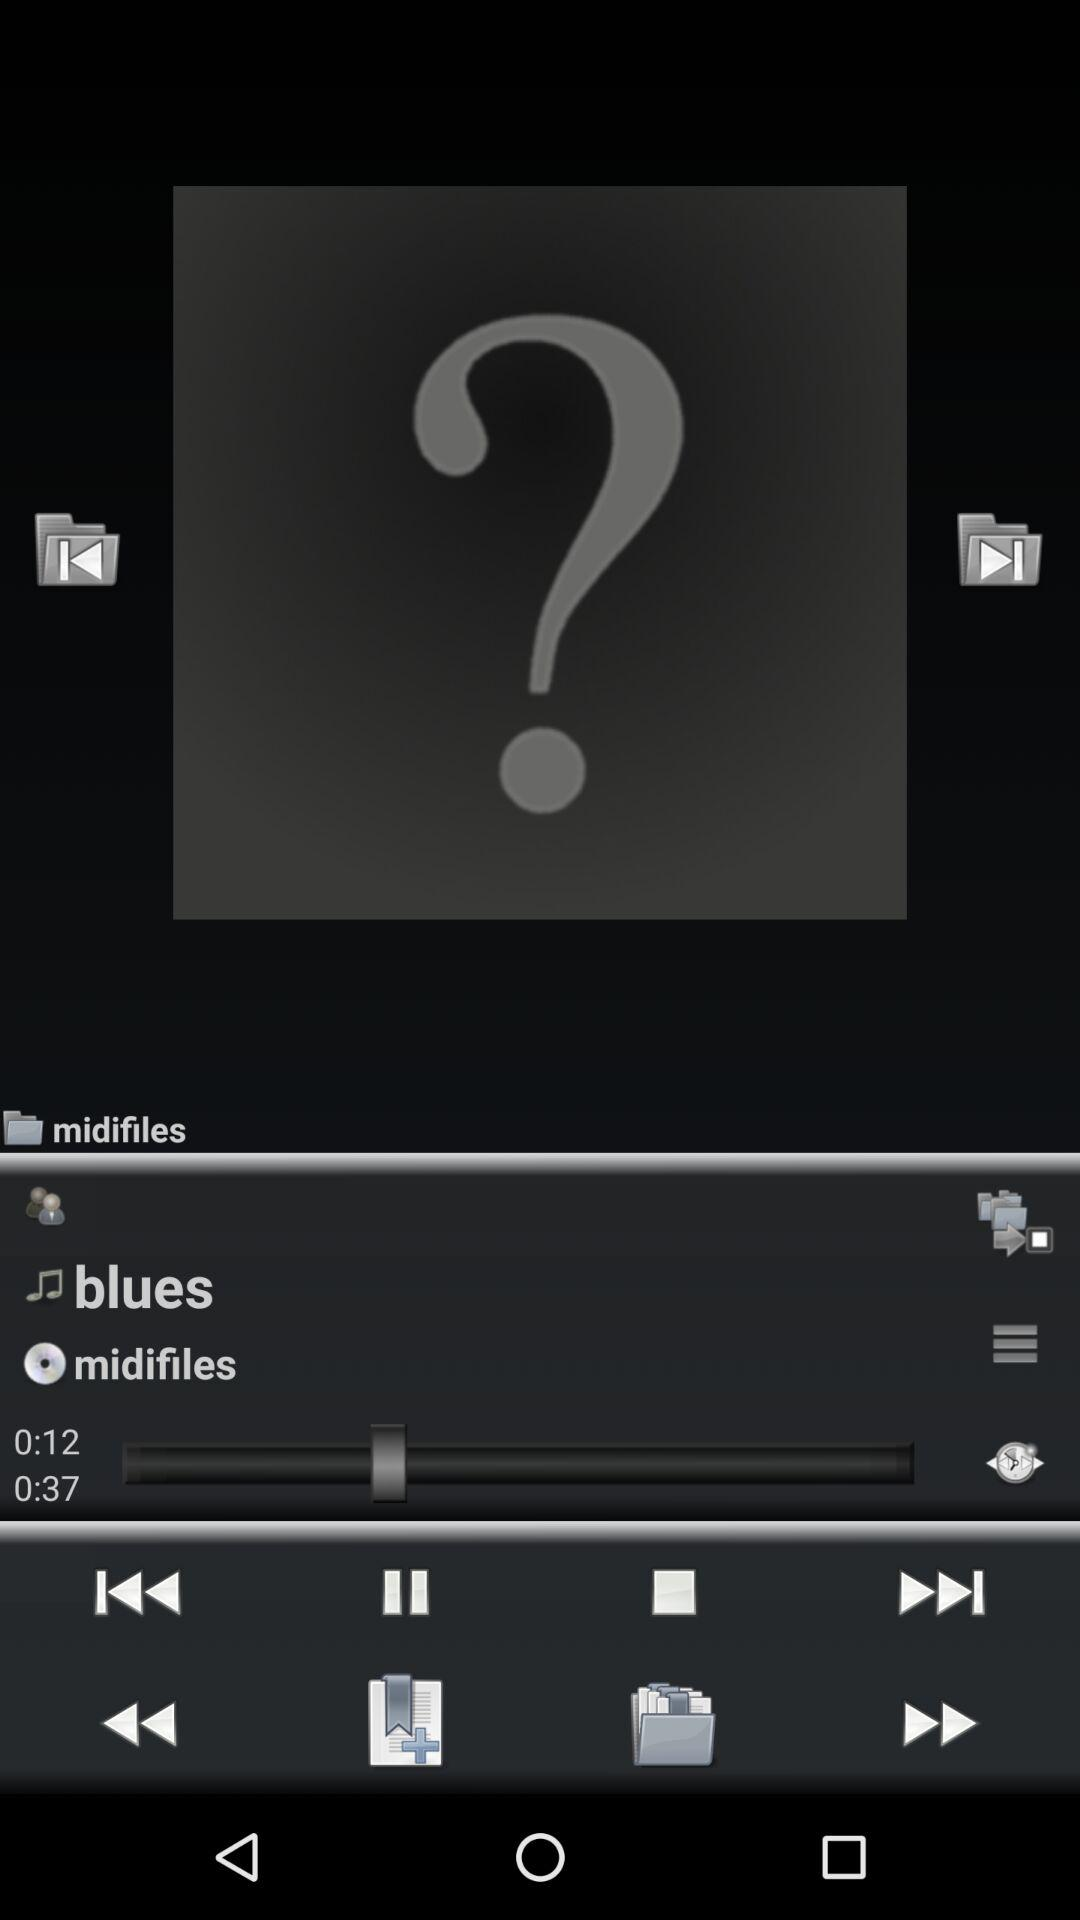What audio is currently playing? The audio currently playing is "blues". 